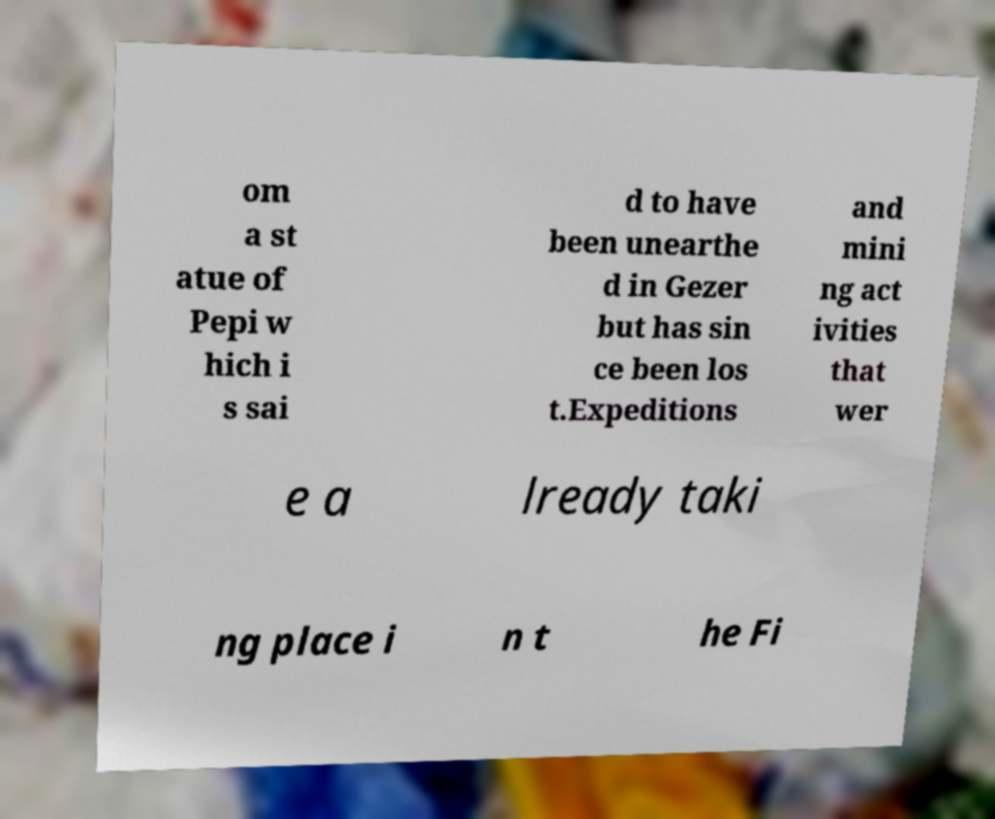Could you assist in decoding the text presented in this image and type it out clearly? om a st atue of Pepi w hich i s sai d to have been unearthe d in Gezer but has sin ce been los t.Expeditions and mini ng act ivities that wer e a lready taki ng place i n t he Fi 